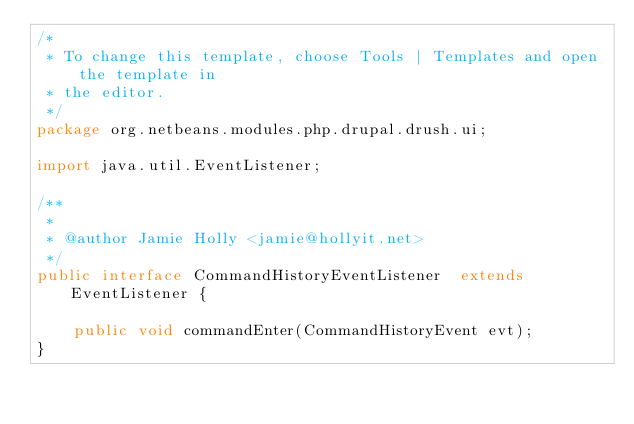Convert code to text. <code><loc_0><loc_0><loc_500><loc_500><_Java_>/*
 * To change this template, choose Tools | Templates and open the template in
 * the editor.
 */
package org.netbeans.modules.php.drupal.drush.ui;

import java.util.EventListener;

/**
 *
 * @author Jamie Holly <jamie@hollyit.net>
 */
public interface CommandHistoryEventListener  extends EventListener {

    public void commandEnter(CommandHistoryEvent evt);
}

</code> 